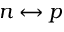<formula> <loc_0><loc_0><loc_500><loc_500>n \leftrightarrow p</formula> 